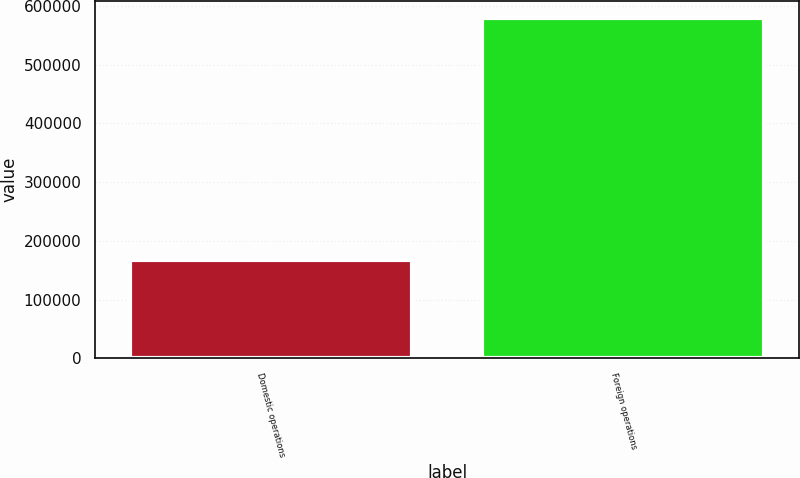<chart> <loc_0><loc_0><loc_500><loc_500><bar_chart><fcel>Domestic operations<fcel>Foreign operations<nl><fcel>168135<fcel>579021<nl></chart> 